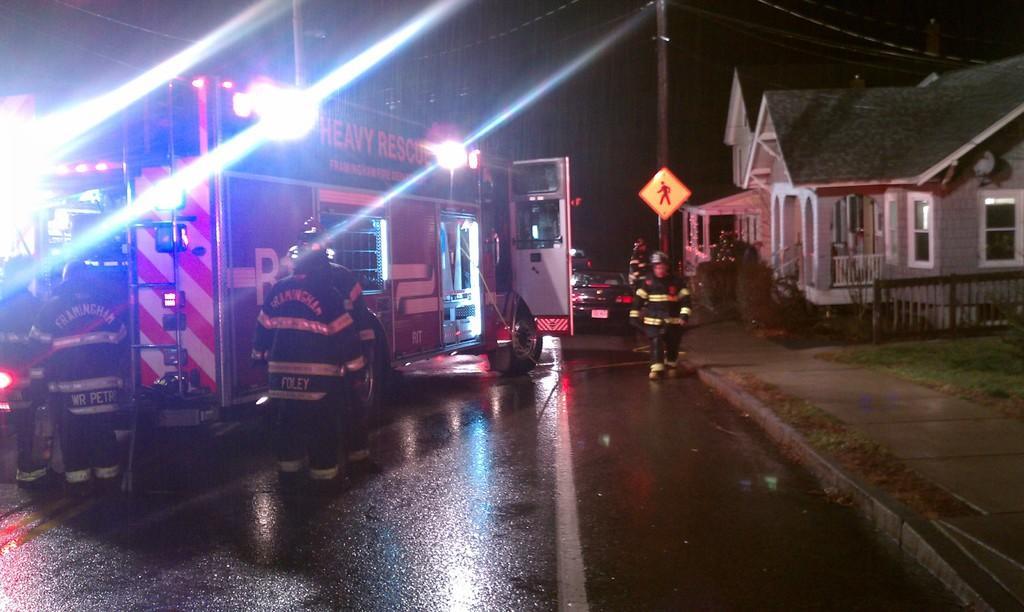Please provide a concise description of this image. In this image we can see a vehicle on the road. And few people are standing here. And right side of the picture there is a house. And even we can see grass here. There is a pole and one sign board is attached to it. And there is a car on the road. Here we can see a person standing on the road. And this is the sky. 